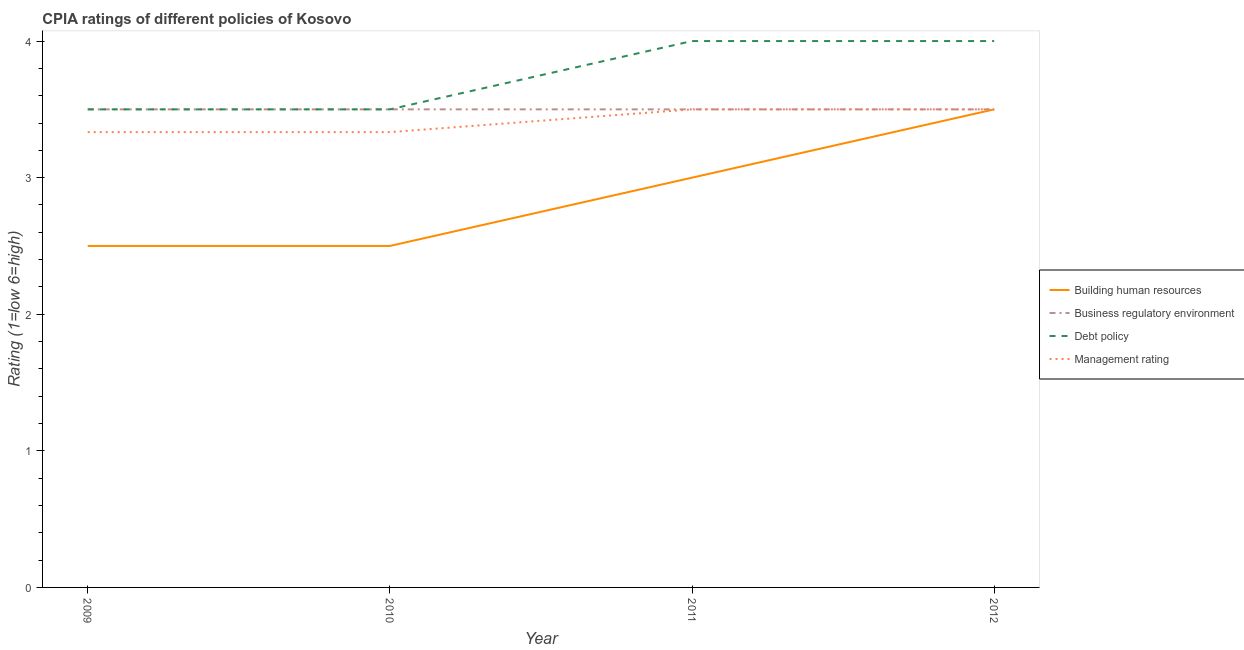Does the line corresponding to cpia rating of building human resources intersect with the line corresponding to cpia rating of management?
Give a very brief answer. Yes. Is the number of lines equal to the number of legend labels?
Your answer should be compact. Yes. Across all years, what is the maximum cpia rating of management?
Make the answer very short. 3.5. Across all years, what is the minimum cpia rating of business regulatory environment?
Your answer should be compact. 3.5. In which year was the cpia rating of management maximum?
Offer a very short reply. 2011. In which year was the cpia rating of debt policy minimum?
Give a very brief answer. 2009. What is the difference between the cpia rating of management in 2009 and that in 2012?
Give a very brief answer. -0.17. What is the difference between the cpia rating of business regulatory environment in 2011 and the cpia rating of debt policy in 2009?
Make the answer very short. 0. What is the average cpia rating of debt policy per year?
Ensure brevity in your answer.  3.75. In the year 2011, what is the difference between the cpia rating of management and cpia rating of debt policy?
Offer a terse response. -0.5. What is the ratio of the cpia rating of management in 2010 to that in 2012?
Ensure brevity in your answer.  0.95. Is the cpia rating of business regulatory environment in 2010 less than that in 2011?
Make the answer very short. No. Is the difference between the cpia rating of building human resources in 2010 and 2012 greater than the difference between the cpia rating of management in 2010 and 2012?
Your response must be concise. No. What is the difference between the highest and the lowest cpia rating of building human resources?
Ensure brevity in your answer.  1. In how many years, is the cpia rating of business regulatory environment greater than the average cpia rating of business regulatory environment taken over all years?
Offer a very short reply. 0. Is the sum of the cpia rating of management in 2010 and 2011 greater than the maximum cpia rating of building human resources across all years?
Keep it short and to the point. Yes. Is it the case that in every year, the sum of the cpia rating of building human resources and cpia rating of management is greater than the sum of cpia rating of business regulatory environment and cpia rating of debt policy?
Your answer should be compact. No. Does the cpia rating of building human resources monotonically increase over the years?
Your response must be concise. No. Is the cpia rating of management strictly less than the cpia rating of debt policy over the years?
Your answer should be very brief. Yes. Are the values on the major ticks of Y-axis written in scientific E-notation?
Your response must be concise. No. Does the graph contain grids?
Your answer should be compact. No. Where does the legend appear in the graph?
Ensure brevity in your answer.  Center right. How are the legend labels stacked?
Provide a succinct answer. Vertical. What is the title of the graph?
Give a very brief answer. CPIA ratings of different policies of Kosovo. What is the label or title of the X-axis?
Keep it short and to the point. Year. What is the label or title of the Y-axis?
Your answer should be very brief. Rating (1=low 6=high). What is the Rating (1=low 6=high) in Building human resources in 2009?
Offer a very short reply. 2.5. What is the Rating (1=low 6=high) of Debt policy in 2009?
Provide a short and direct response. 3.5. What is the Rating (1=low 6=high) in Management rating in 2009?
Provide a short and direct response. 3.33. What is the Rating (1=low 6=high) in Business regulatory environment in 2010?
Give a very brief answer. 3.5. What is the Rating (1=low 6=high) of Management rating in 2010?
Provide a short and direct response. 3.33. What is the Rating (1=low 6=high) in Business regulatory environment in 2011?
Offer a terse response. 3.5. What is the Rating (1=low 6=high) in Business regulatory environment in 2012?
Offer a very short reply. 3.5. What is the Rating (1=low 6=high) in Management rating in 2012?
Your answer should be compact. 3.5. Across all years, what is the maximum Rating (1=low 6=high) of Building human resources?
Offer a terse response. 3.5. Across all years, what is the maximum Rating (1=low 6=high) of Business regulatory environment?
Provide a succinct answer. 3.5. Across all years, what is the maximum Rating (1=low 6=high) in Management rating?
Ensure brevity in your answer.  3.5. Across all years, what is the minimum Rating (1=low 6=high) in Building human resources?
Make the answer very short. 2.5. Across all years, what is the minimum Rating (1=low 6=high) of Business regulatory environment?
Your answer should be compact. 3.5. Across all years, what is the minimum Rating (1=low 6=high) of Debt policy?
Keep it short and to the point. 3.5. Across all years, what is the minimum Rating (1=low 6=high) in Management rating?
Your answer should be very brief. 3.33. What is the total Rating (1=low 6=high) in Business regulatory environment in the graph?
Provide a succinct answer. 14. What is the total Rating (1=low 6=high) in Management rating in the graph?
Offer a very short reply. 13.67. What is the difference between the Rating (1=low 6=high) in Business regulatory environment in 2009 and that in 2010?
Ensure brevity in your answer.  0. What is the difference between the Rating (1=low 6=high) in Debt policy in 2009 and that in 2010?
Give a very brief answer. 0. What is the difference between the Rating (1=low 6=high) in Business regulatory environment in 2009 and that in 2011?
Keep it short and to the point. 0. What is the difference between the Rating (1=low 6=high) in Management rating in 2009 and that in 2012?
Keep it short and to the point. -0.17. What is the difference between the Rating (1=low 6=high) in Debt policy in 2010 and that in 2011?
Provide a succinct answer. -0.5. What is the difference between the Rating (1=low 6=high) in Management rating in 2010 and that in 2011?
Ensure brevity in your answer.  -0.17. What is the difference between the Rating (1=low 6=high) in Building human resources in 2010 and that in 2012?
Provide a succinct answer. -1. What is the difference between the Rating (1=low 6=high) in Business regulatory environment in 2010 and that in 2012?
Ensure brevity in your answer.  0. What is the difference between the Rating (1=low 6=high) in Management rating in 2010 and that in 2012?
Offer a terse response. -0.17. What is the difference between the Rating (1=low 6=high) of Building human resources in 2011 and that in 2012?
Ensure brevity in your answer.  -0.5. What is the difference between the Rating (1=low 6=high) in Business regulatory environment in 2011 and that in 2012?
Offer a terse response. 0. What is the difference between the Rating (1=low 6=high) of Debt policy in 2011 and that in 2012?
Offer a very short reply. 0. What is the difference between the Rating (1=low 6=high) in Building human resources in 2009 and the Rating (1=low 6=high) in Business regulatory environment in 2010?
Provide a succinct answer. -1. What is the difference between the Rating (1=low 6=high) in Business regulatory environment in 2009 and the Rating (1=low 6=high) in Debt policy in 2010?
Provide a short and direct response. 0. What is the difference between the Rating (1=low 6=high) of Building human resources in 2009 and the Rating (1=low 6=high) of Business regulatory environment in 2011?
Offer a terse response. -1. What is the difference between the Rating (1=low 6=high) of Building human resources in 2009 and the Rating (1=low 6=high) of Debt policy in 2011?
Offer a terse response. -1.5. What is the difference between the Rating (1=low 6=high) in Building human resources in 2009 and the Rating (1=low 6=high) in Business regulatory environment in 2012?
Keep it short and to the point. -1. What is the difference between the Rating (1=low 6=high) of Building human resources in 2009 and the Rating (1=low 6=high) of Debt policy in 2012?
Keep it short and to the point. -1.5. What is the difference between the Rating (1=low 6=high) of Building human resources in 2009 and the Rating (1=low 6=high) of Management rating in 2012?
Give a very brief answer. -1. What is the difference between the Rating (1=low 6=high) of Building human resources in 2010 and the Rating (1=low 6=high) of Debt policy in 2011?
Offer a terse response. -1.5. What is the difference between the Rating (1=low 6=high) in Building human resources in 2010 and the Rating (1=low 6=high) in Management rating in 2011?
Keep it short and to the point. -1. What is the difference between the Rating (1=low 6=high) of Business regulatory environment in 2010 and the Rating (1=low 6=high) of Management rating in 2011?
Your answer should be very brief. 0. What is the difference between the Rating (1=low 6=high) of Debt policy in 2010 and the Rating (1=low 6=high) of Management rating in 2011?
Offer a terse response. 0. What is the difference between the Rating (1=low 6=high) of Building human resources in 2010 and the Rating (1=low 6=high) of Business regulatory environment in 2012?
Make the answer very short. -1. What is the difference between the Rating (1=low 6=high) in Building human resources in 2010 and the Rating (1=low 6=high) in Management rating in 2012?
Keep it short and to the point. -1. What is the difference between the Rating (1=low 6=high) in Debt policy in 2010 and the Rating (1=low 6=high) in Management rating in 2012?
Your response must be concise. 0. What is the difference between the Rating (1=low 6=high) in Building human resources in 2011 and the Rating (1=low 6=high) in Management rating in 2012?
Provide a succinct answer. -0.5. What is the difference between the Rating (1=low 6=high) in Debt policy in 2011 and the Rating (1=low 6=high) in Management rating in 2012?
Your answer should be very brief. 0.5. What is the average Rating (1=low 6=high) of Building human resources per year?
Keep it short and to the point. 2.88. What is the average Rating (1=low 6=high) in Debt policy per year?
Give a very brief answer. 3.75. What is the average Rating (1=low 6=high) in Management rating per year?
Provide a short and direct response. 3.42. In the year 2009, what is the difference between the Rating (1=low 6=high) of Building human resources and Rating (1=low 6=high) of Business regulatory environment?
Ensure brevity in your answer.  -1. In the year 2009, what is the difference between the Rating (1=low 6=high) of Building human resources and Rating (1=low 6=high) of Debt policy?
Make the answer very short. -1. In the year 2009, what is the difference between the Rating (1=low 6=high) of Building human resources and Rating (1=low 6=high) of Management rating?
Provide a succinct answer. -0.83. In the year 2009, what is the difference between the Rating (1=low 6=high) in Business regulatory environment and Rating (1=low 6=high) in Debt policy?
Make the answer very short. 0. In the year 2011, what is the difference between the Rating (1=low 6=high) in Building human resources and Rating (1=low 6=high) in Business regulatory environment?
Provide a short and direct response. -0.5. In the year 2011, what is the difference between the Rating (1=low 6=high) of Building human resources and Rating (1=low 6=high) of Management rating?
Offer a very short reply. -0.5. In the year 2011, what is the difference between the Rating (1=low 6=high) of Business regulatory environment and Rating (1=low 6=high) of Debt policy?
Provide a short and direct response. -0.5. In the year 2011, what is the difference between the Rating (1=low 6=high) of Business regulatory environment and Rating (1=low 6=high) of Management rating?
Give a very brief answer. 0. In the year 2011, what is the difference between the Rating (1=low 6=high) of Debt policy and Rating (1=low 6=high) of Management rating?
Ensure brevity in your answer.  0.5. In the year 2012, what is the difference between the Rating (1=low 6=high) in Building human resources and Rating (1=low 6=high) in Business regulatory environment?
Your answer should be compact. 0. In the year 2012, what is the difference between the Rating (1=low 6=high) in Debt policy and Rating (1=low 6=high) in Management rating?
Your response must be concise. 0.5. What is the ratio of the Rating (1=low 6=high) in Business regulatory environment in 2009 to that in 2010?
Make the answer very short. 1. What is the ratio of the Rating (1=low 6=high) of Debt policy in 2009 to that in 2010?
Give a very brief answer. 1. What is the ratio of the Rating (1=low 6=high) of Management rating in 2009 to that in 2010?
Offer a very short reply. 1. What is the ratio of the Rating (1=low 6=high) of Building human resources in 2009 to that in 2011?
Ensure brevity in your answer.  0.83. What is the ratio of the Rating (1=low 6=high) in Management rating in 2009 to that in 2011?
Ensure brevity in your answer.  0.95. What is the ratio of the Rating (1=low 6=high) in Debt policy in 2010 to that in 2012?
Make the answer very short. 0.88. What is the ratio of the Rating (1=low 6=high) in Building human resources in 2011 to that in 2012?
Your answer should be very brief. 0.86. What is the ratio of the Rating (1=low 6=high) in Business regulatory environment in 2011 to that in 2012?
Your answer should be compact. 1. What is the ratio of the Rating (1=low 6=high) in Management rating in 2011 to that in 2012?
Provide a short and direct response. 1. What is the difference between the highest and the second highest Rating (1=low 6=high) of Building human resources?
Keep it short and to the point. 0.5. What is the difference between the highest and the lowest Rating (1=low 6=high) of Business regulatory environment?
Your answer should be compact. 0. What is the difference between the highest and the lowest Rating (1=low 6=high) of Management rating?
Provide a succinct answer. 0.17. 